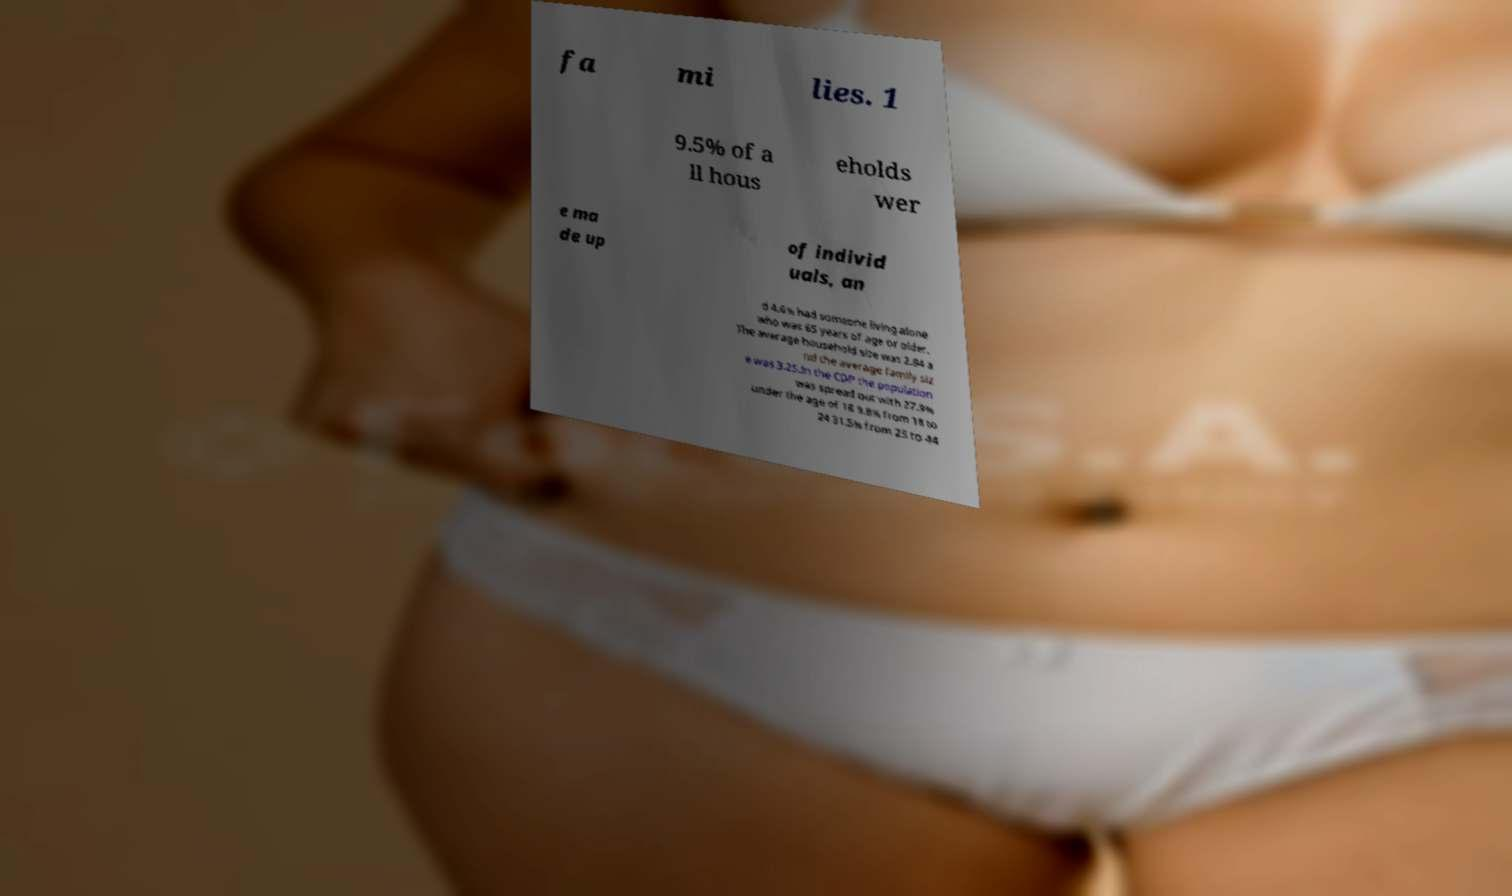Please read and relay the text visible in this image. What does it say? fa mi lies. 1 9.5% of a ll hous eholds wer e ma de up of individ uals, an d 4.6% had someone living alone who was 65 years of age or older. The average household size was 2.84 a nd the average family siz e was 3.25.In the CDP the population was spread out with 27.9% under the age of 18 9.8% from 18 to 24 31.5% from 25 to 44 